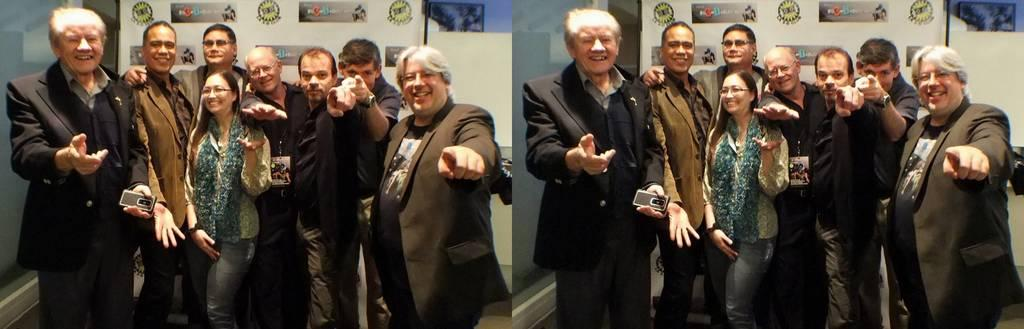What is happening in the image? There is a group of people in the image, and they are standing and smiling. What are some of the people wearing? Some of the people are wearing suits. What can be seen in the background of the image? There are white color walls in the background of the image. How many pigs are in the image? There are no pigs present in the image. 